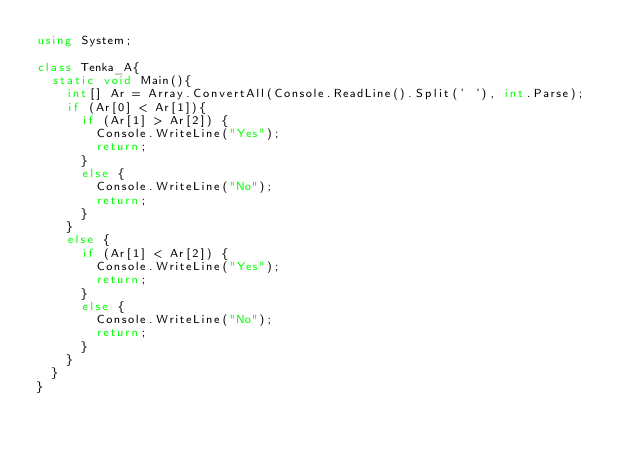Convert code to text. <code><loc_0><loc_0><loc_500><loc_500><_C#_>using System;

class Tenka_A{
  static void Main(){
    int[] Ar = Array.ConvertAll(Console.ReadLine().Split(' '), int.Parse);
    if (Ar[0] < Ar[1]){
      if (Ar[1] > Ar[2]) {
        Console.WriteLine("Yes");
        return;
      }
      else {
        Console.WriteLine("No");
        return;
      }
    }
    else {
      if (Ar[1] < Ar[2]) {
        Console.WriteLine("Yes");
        return;
      }
      else {
        Console.WriteLine("No");
        return;
      }
    }
  }
}</code> 